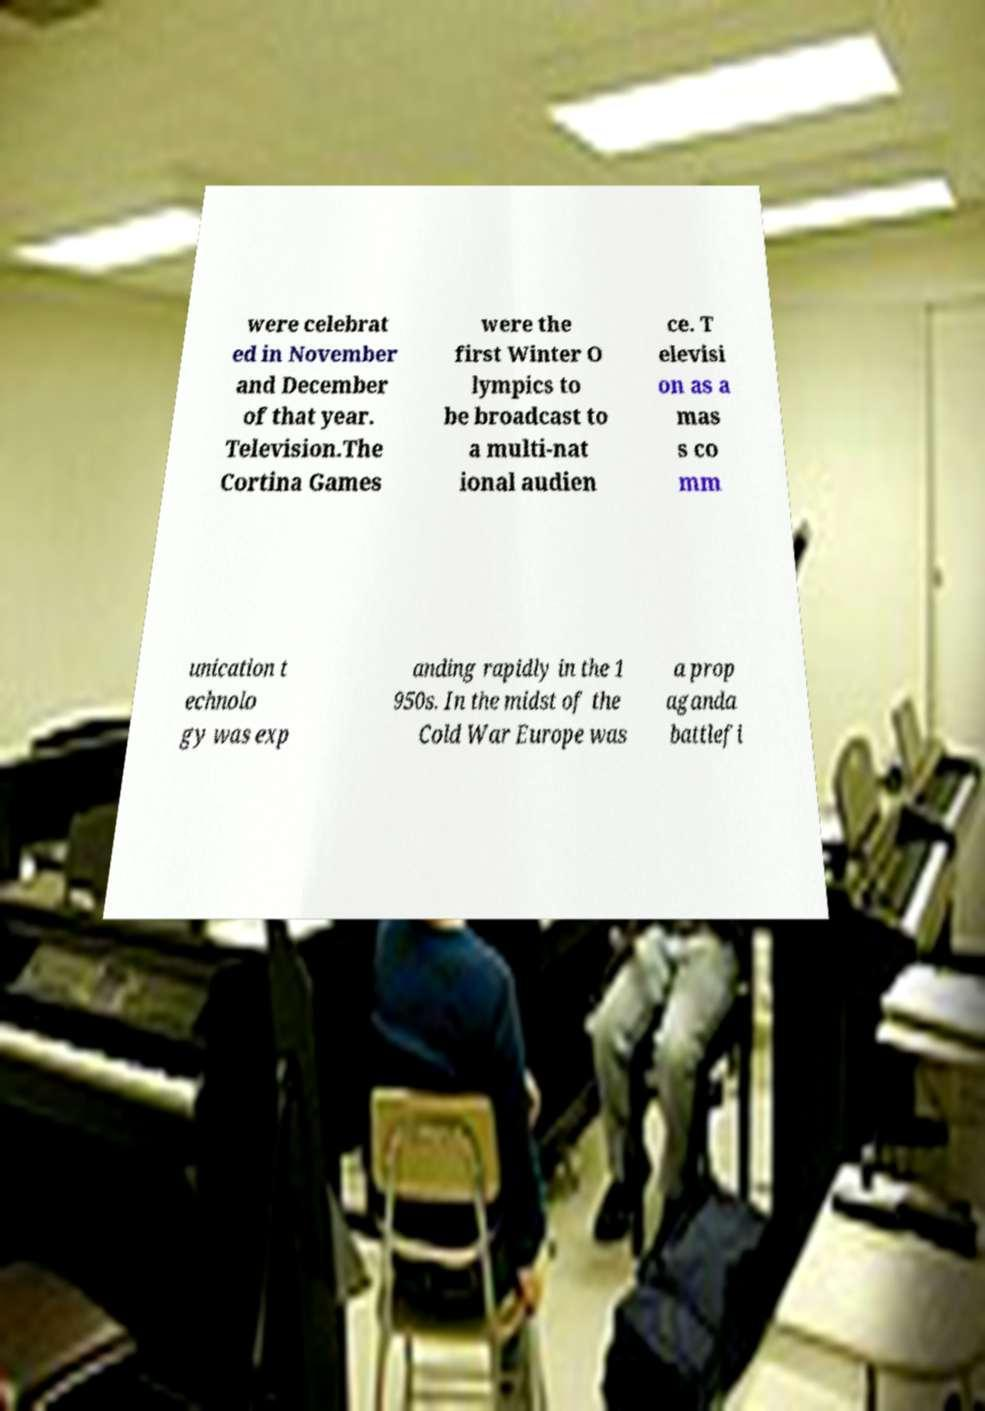For documentation purposes, I need the text within this image transcribed. Could you provide that? were celebrat ed in November and December of that year. Television.The Cortina Games were the first Winter O lympics to be broadcast to a multi-nat ional audien ce. T elevisi on as a mas s co mm unication t echnolo gy was exp anding rapidly in the 1 950s. In the midst of the Cold War Europe was a prop aganda battlefi 